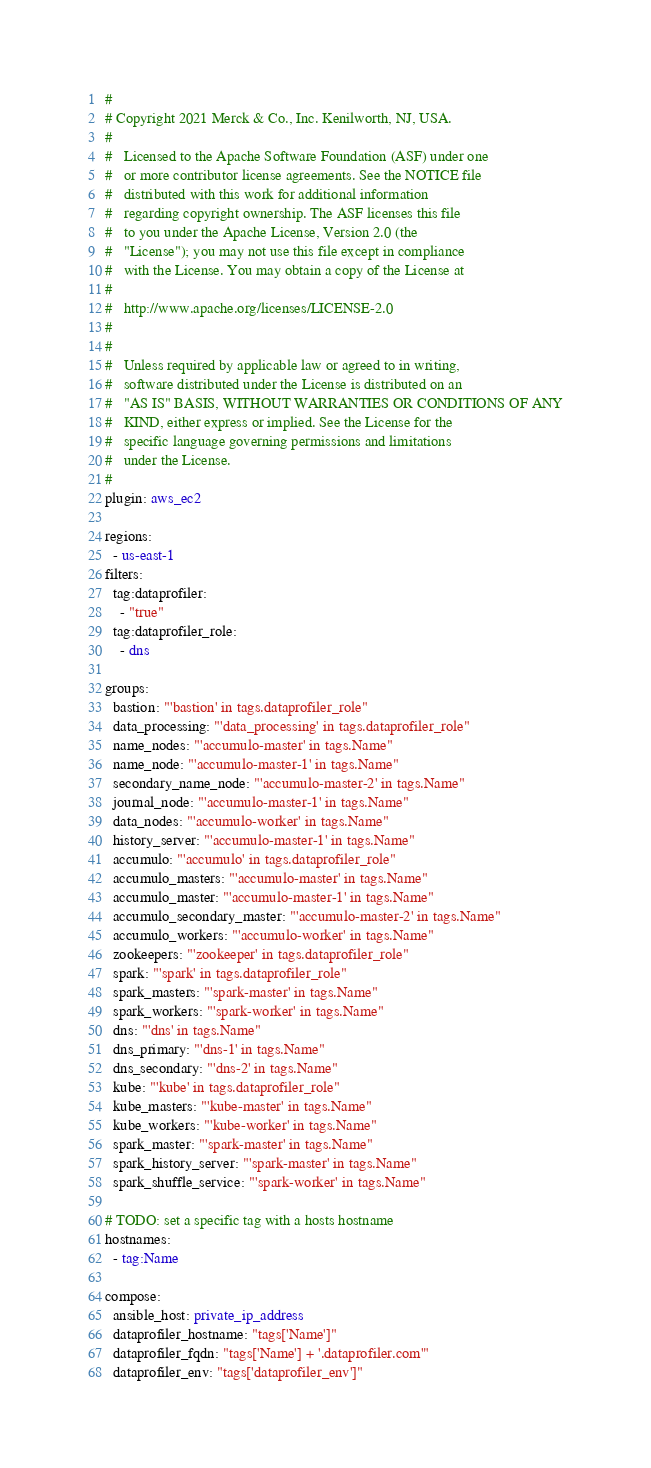<code> <loc_0><loc_0><loc_500><loc_500><_YAML_>#
# Copyright 2021 Merck & Co., Inc. Kenilworth, NJ, USA.
#
#	Licensed to the Apache Software Foundation (ASF) under one
#	or more contributor license agreements. See the NOTICE file
#	distributed with this work for additional information
#	regarding copyright ownership. The ASF licenses this file
#	to you under the Apache License, Version 2.0 (the
#	"License"); you may not use this file except in compliance
#	with the License. You may obtain a copy of the License at
#
#	http://www.apache.org/licenses/LICENSE-2.0
#
#
#	Unless required by applicable law or agreed to in writing,
#	software distributed under the License is distributed on an
#	"AS IS" BASIS, WITHOUT WARRANTIES OR CONDITIONS OF ANY
#	KIND, either express or implied. See the License for the
#	specific language governing permissions and limitations
#	under the License.
#
plugin: aws_ec2

regions:
  - us-east-1
filters:
  tag:dataprofiler:
    - "true"
  tag:dataprofiler_role:
    - dns

groups:
  bastion: "'bastion' in tags.dataprofiler_role"
  data_processing: "'data_processing' in tags.dataprofiler_role"
  name_nodes: "'accumulo-master' in tags.Name"
  name_node: "'accumulo-master-1' in tags.Name"
  secondary_name_node: "'accumulo-master-2' in tags.Name"
  journal_node: "'accumulo-master-1' in tags.Name"
  data_nodes: "'accumulo-worker' in tags.Name"
  history_server: "'accumulo-master-1' in tags.Name"
  accumulo: "'accumulo' in tags.dataprofiler_role"
  accumulo_masters: "'accumulo-master' in tags.Name"
  accumulo_master: "'accumulo-master-1' in tags.Name"
  accumulo_secondary_master: "'accumulo-master-2' in tags.Name"
  accumulo_workers: "'accumulo-worker' in tags.Name"
  zookeepers: "'zookeeper' in tags.dataprofiler_role"
  spark: "'spark' in tags.dataprofiler_role"
  spark_masters: "'spark-master' in tags.Name"
  spark_workers: "'spark-worker' in tags.Name"
  dns: "'dns' in tags.Name"
  dns_primary: "'dns-1' in tags.Name"
  dns_secondary: "'dns-2' in tags.Name"
  kube: "'kube' in tags.dataprofiler_role"
  kube_masters: "'kube-master' in tags.Name" 
  kube_workers: "'kube-worker' in tags.Name"
  spark_master: "'spark-master' in tags.Name"
  spark_history_server: "'spark-master' in tags.Name"
  spark_shuffle_service: "'spark-worker' in tags.Name"

# TODO: set a specific tag with a hosts hostname
hostnames:
  - tag:Name

compose:
  ansible_host: private_ip_address
  dataprofiler_hostname: "tags['Name']"
  dataprofiler_fqdn: "tags['Name'] + '.dataprofiler.com'"
  dataprofiler_env: "tags['dataprofiler_env']"
</code> 